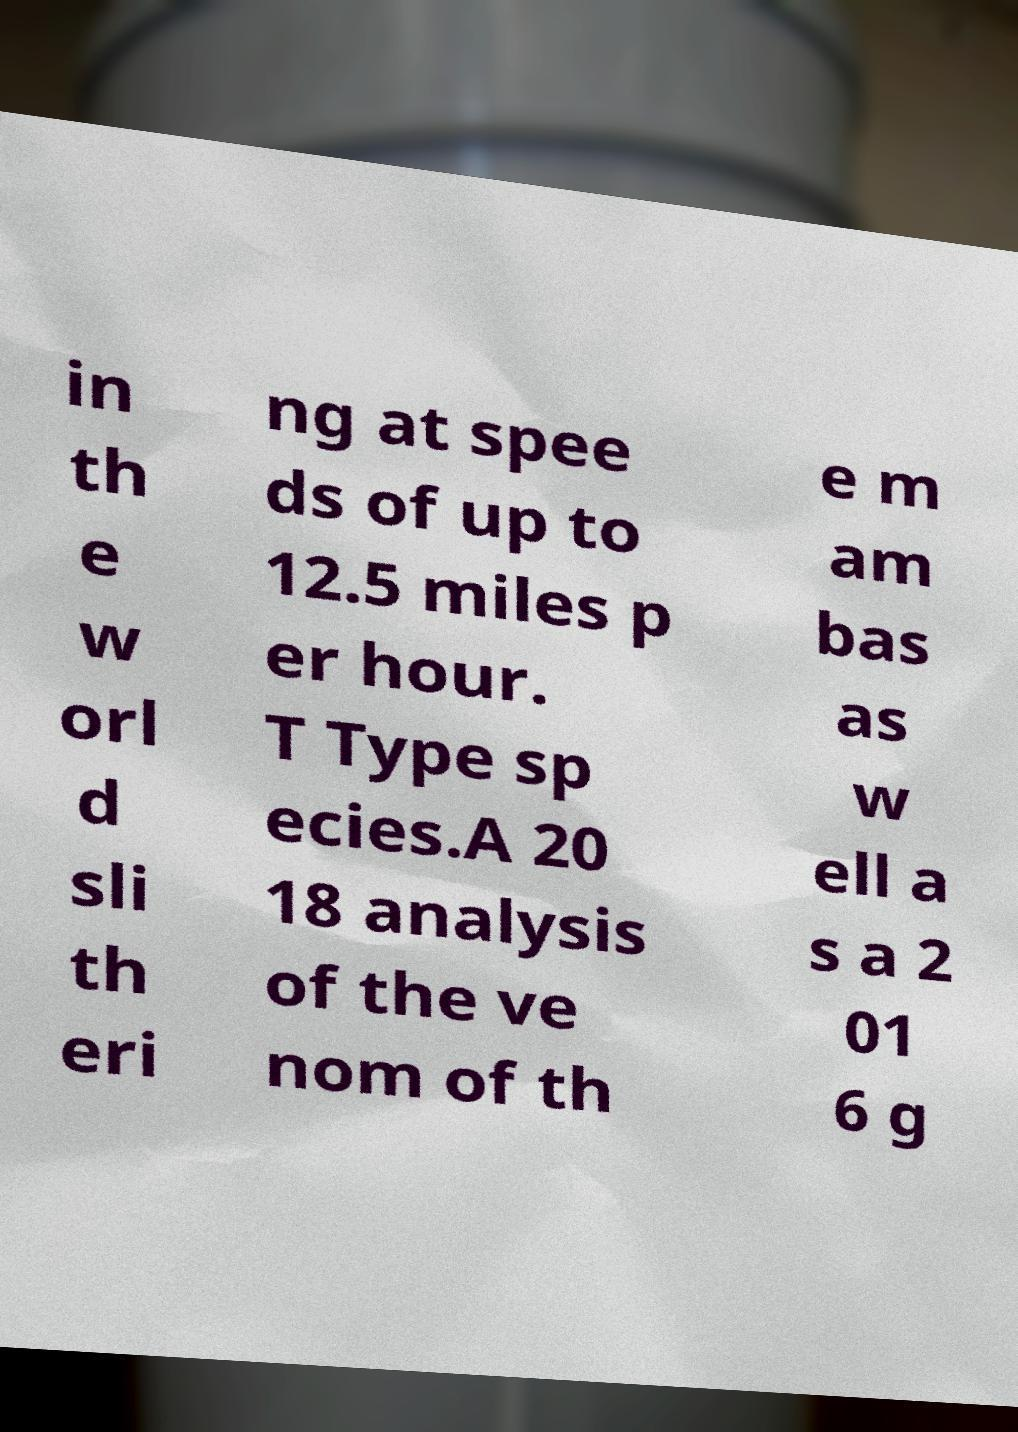What messages or text are displayed in this image? I need them in a readable, typed format. in th e w orl d sli th eri ng at spee ds of up to 12.5 miles p er hour. T Type sp ecies.A 20 18 analysis of the ve nom of th e m am bas as w ell a s a 2 01 6 g 